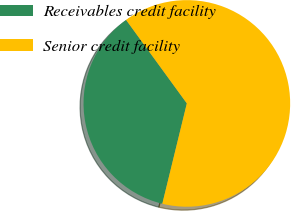<chart> <loc_0><loc_0><loc_500><loc_500><pie_chart><fcel>Receivables credit facility<fcel>Senior credit facility<nl><fcel>36.17%<fcel>63.83%<nl></chart> 